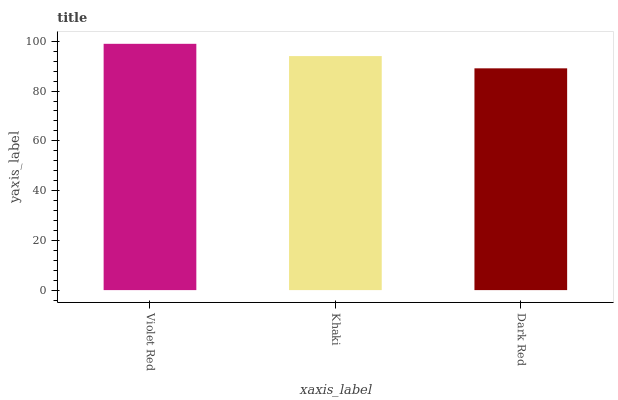Is Dark Red the minimum?
Answer yes or no. Yes. Is Violet Red the maximum?
Answer yes or no. Yes. Is Khaki the minimum?
Answer yes or no. No. Is Khaki the maximum?
Answer yes or no. No. Is Violet Red greater than Khaki?
Answer yes or no. Yes. Is Khaki less than Violet Red?
Answer yes or no. Yes. Is Khaki greater than Violet Red?
Answer yes or no. No. Is Violet Red less than Khaki?
Answer yes or no. No. Is Khaki the high median?
Answer yes or no. Yes. Is Khaki the low median?
Answer yes or no. Yes. Is Dark Red the high median?
Answer yes or no. No. Is Dark Red the low median?
Answer yes or no. No. 